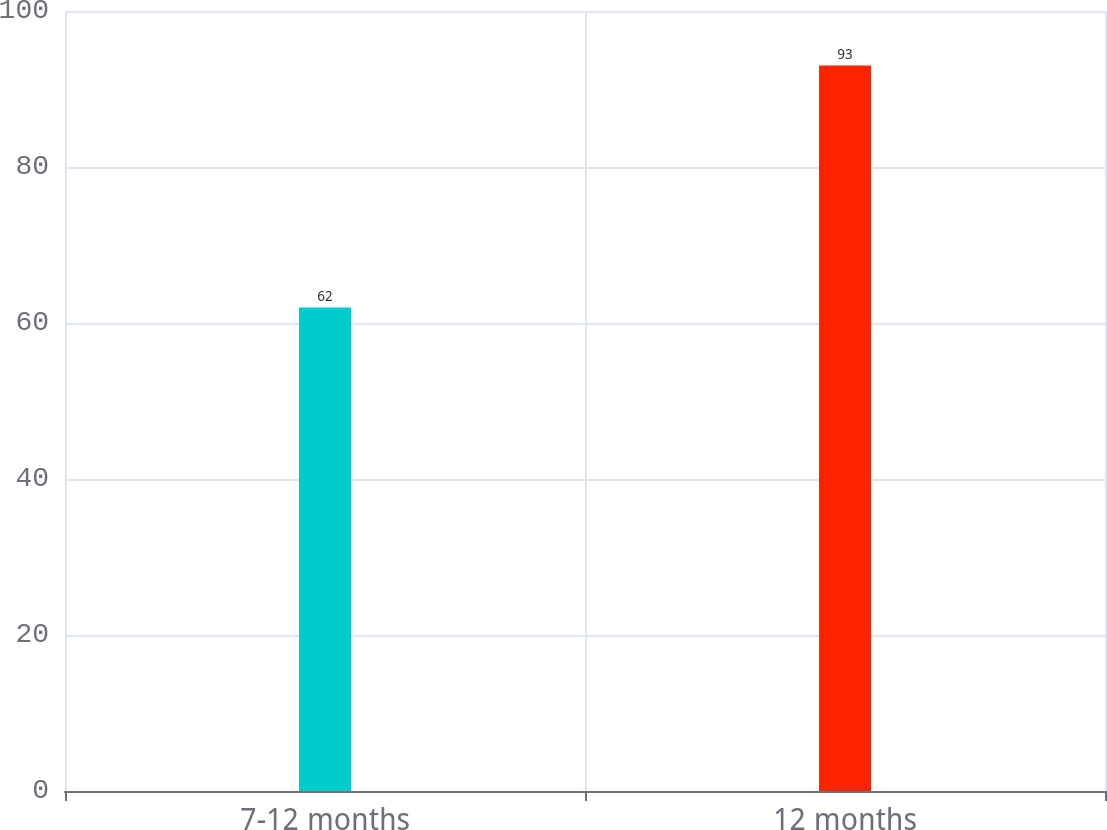<chart> <loc_0><loc_0><loc_500><loc_500><bar_chart><fcel>7-12 months<fcel>12 months<nl><fcel>62<fcel>93<nl></chart> 